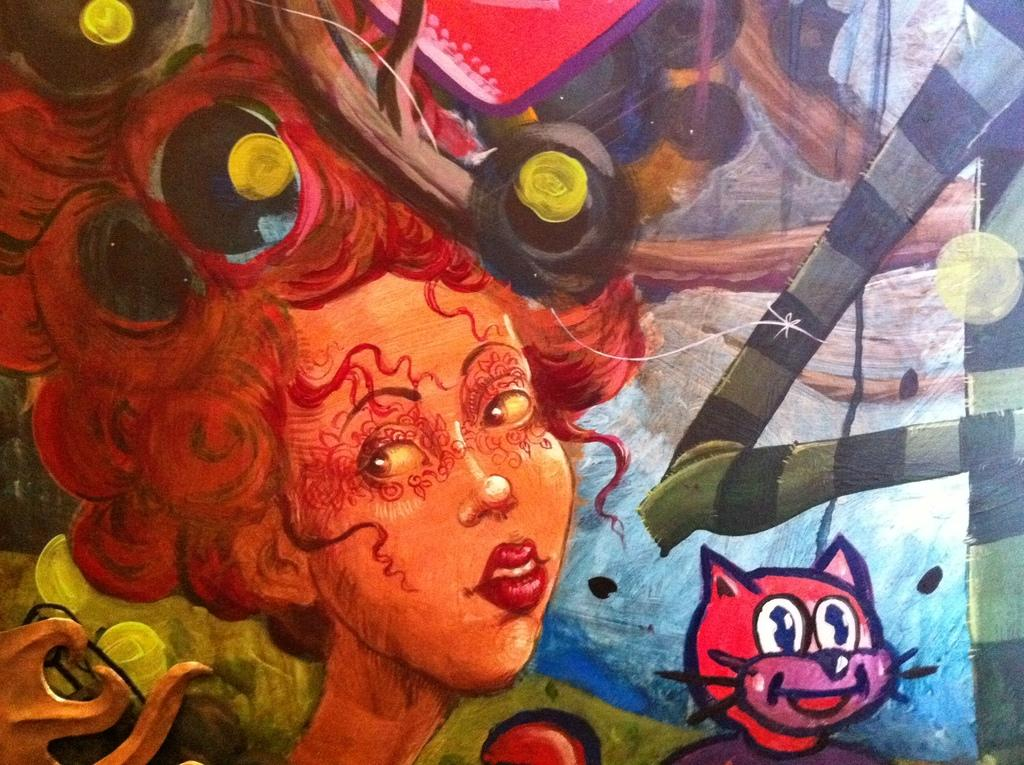What is the main subject of the image? There is a painting in the image. What is depicted in the painting? The painting depicts a person and a toy. Can you describe the painting's appearance? The painting is colorful. What type of twig is being used to write on the painting in the image? There is no twig or writing on the painting in the image; it is a static image of a person and a toy. Is the queen present in the painting in the image? The provided facts do not mention the presence of a queen in the painting. 